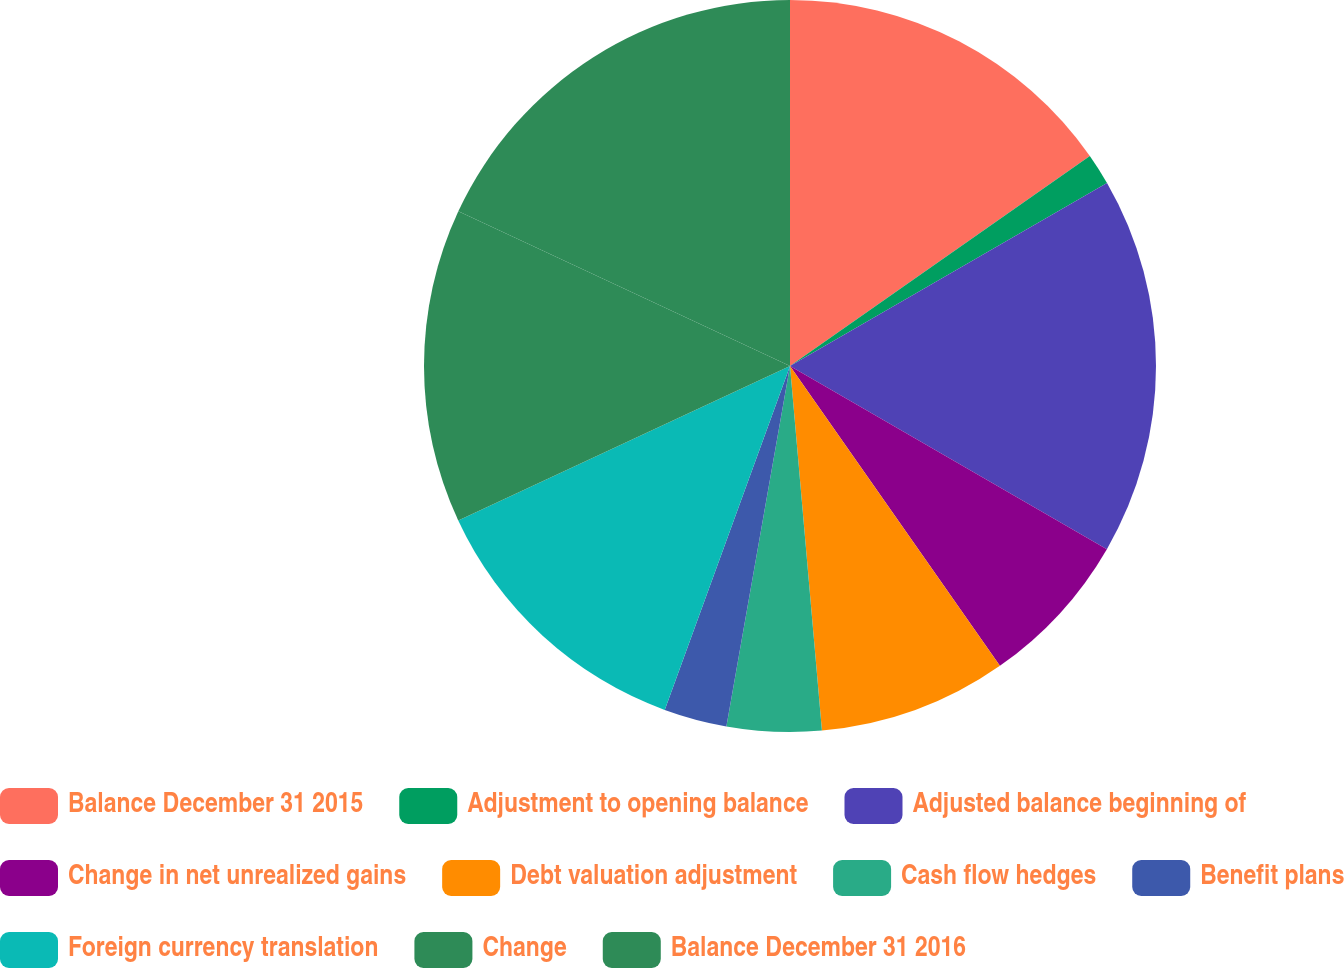Convert chart to OTSL. <chart><loc_0><loc_0><loc_500><loc_500><pie_chart><fcel>Balance December 31 2015<fcel>Adjustment to opening balance<fcel>Adjusted balance beginning of<fcel>Change in net unrealized gains<fcel>Debt valuation adjustment<fcel>Cash flow hedges<fcel>Benefit plans<fcel>Foreign currency translation<fcel>Change<fcel>Balance December 31 2016<nl><fcel>15.28%<fcel>1.39%<fcel>16.67%<fcel>6.94%<fcel>8.33%<fcel>4.17%<fcel>2.78%<fcel>12.5%<fcel>13.89%<fcel>18.05%<nl></chart> 